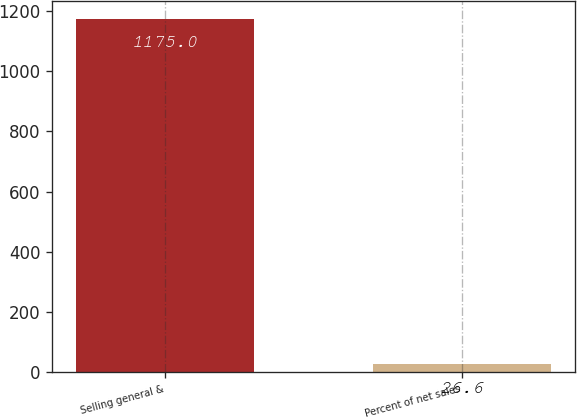Convert chart to OTSL. <chart><loc_0><loc_0><loc_500><loc_500><bar_chart><fcel>Selling general &<fcel>Percent of net sales<nl><fcel>1175<fcel>26.6<nl></chart> 